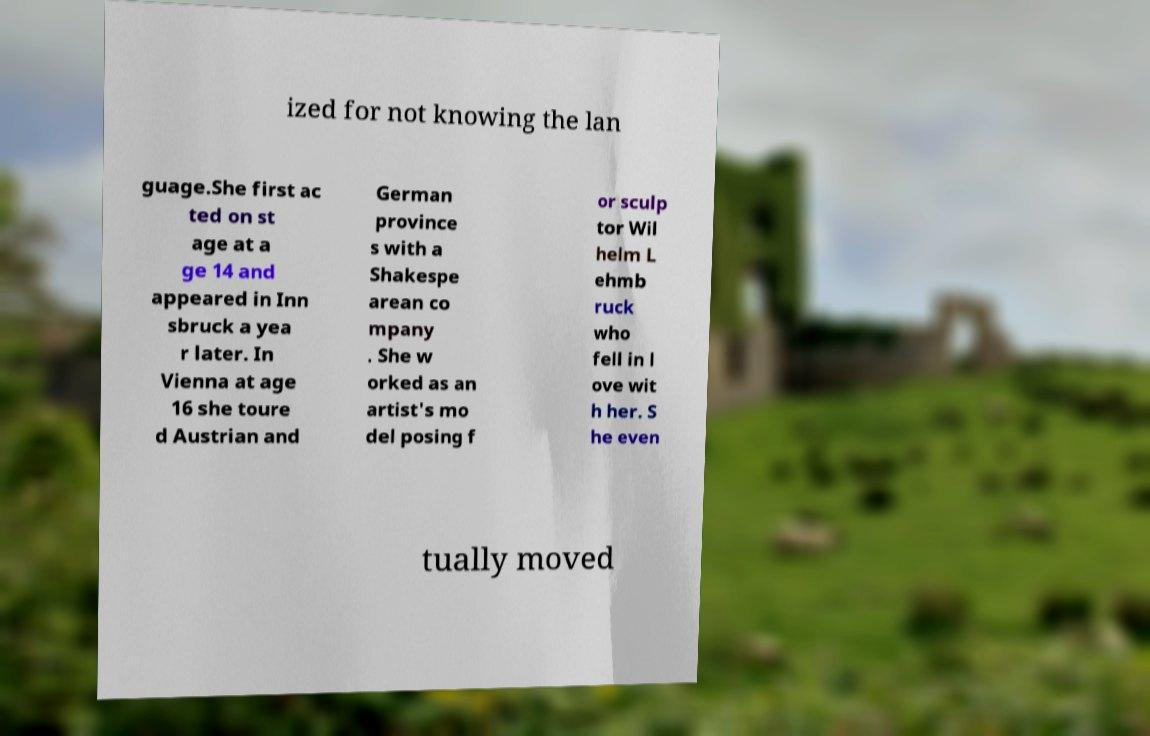Please identify and transcribe the text found in this image. ized for not knowing the lan guage.She first ac ted on st age at a ge 14 and appeared in Inn sbruck a yea r later. In Vienna at age 16 she toure d Austrian and German province s with a Shakespe arean co mpany . She w orked as an artist's mo del posing f or sculp tor Wil helm L ehmb ruck who fell in l ove wit h her. S he even tually moved 